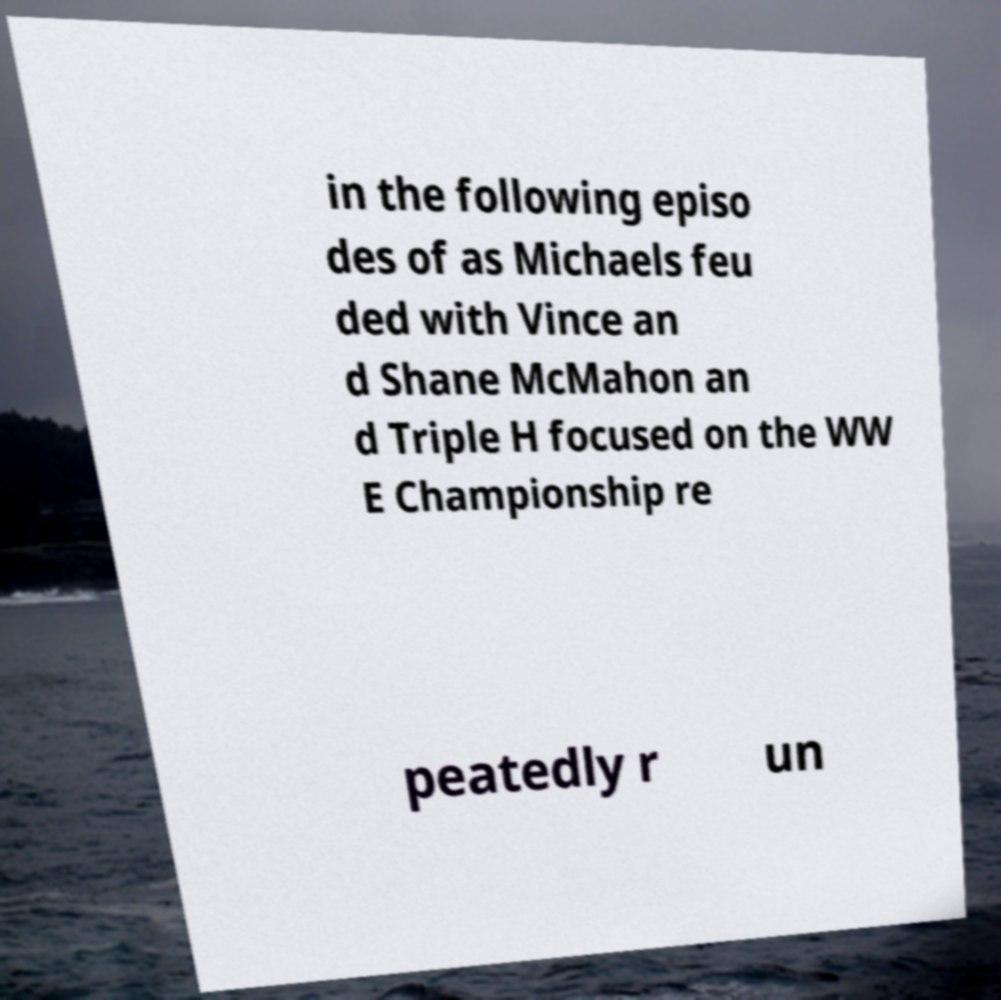I need the written content from this picture converted into text. Can you do that? in the following episo des of as Michaels feu ded with Vince an d Shane McMahon an d Triple H focused on the WW E Championship re peatedly r un 